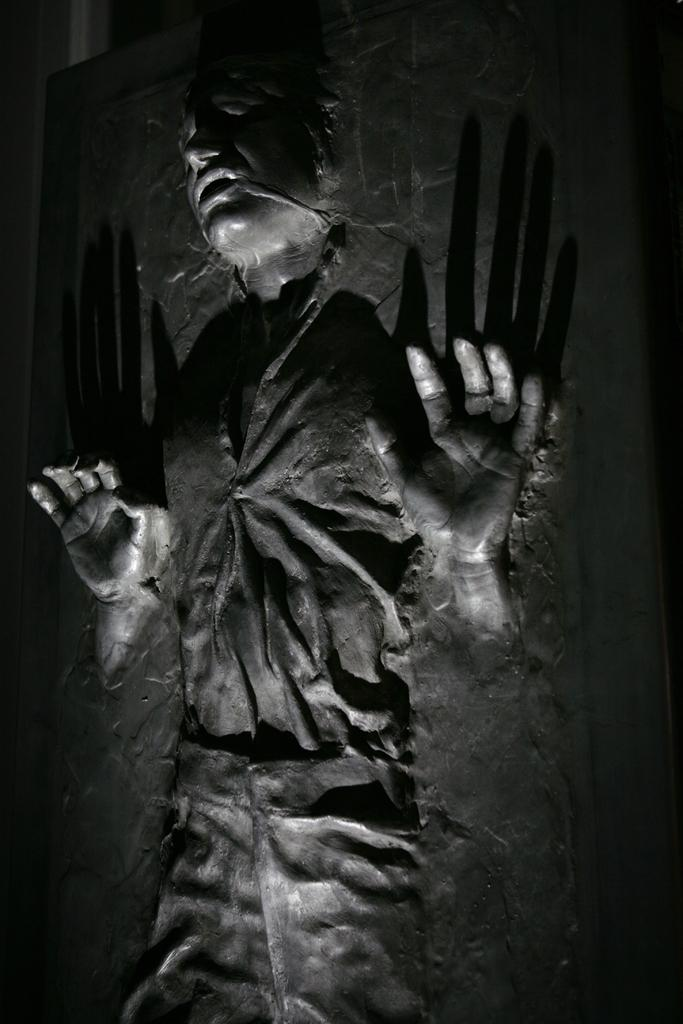What is present on the wall in the image? There is a person sculpture attached to the wall in the image. Can you describe the person sculpture? The person sculpture is attached to the wall. What is the tax rate for the unit in the image? There is no information about tax or units in the image; it only features a wall with a person sculpture attached to it. What type of teeth does the person sculpture have? The person sculpture is not a living being and does not have teeth. 